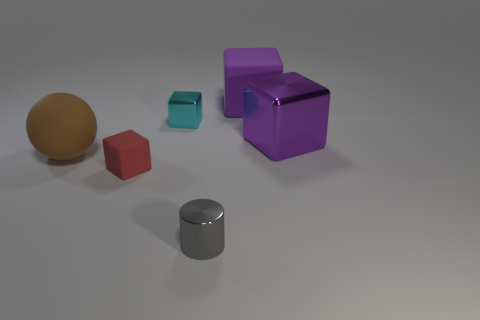What material is the thing that is on the left side of the small block in front of the large purple object that is in front of the large rubber cube made of?
Give a very brief answer. Rubber. Are there any cyan things of the same size as the metallic cylinder?
Keep it short and to the point. Yes. What is the shape of the small cyan shiny thing?
Your response must be concise. Cube. How many blocks are purple metal objects or small red matte things?
Your answer should be compact. 2. Are there an equal number of brown things that are right of the small gray object and large rubber objects that are in front of the tiny cyan metallic thing?
Keep it short and to the point. No. There is a large purple block in front of the purple cube left of the big metallic block; what number of large matte objects are in front of it?
Your answer should be compact. 1. What shape is the large shiny object that is the same color as the big matte cube?
Your answer should be compact. Cube. Does the tiny rubber block have the same color as the tiny shiny thing that is in front of the ball?
Ensure brevity in your answer.  No. Are there more small gray things behind the purple shiny thing than purple matte cubes?
Provide a succinct answer. No. How many things are big things to the left of the small metallic cylinder or blocks on the right side of the tiny cylinder?
Give a very brief answer. 3. 